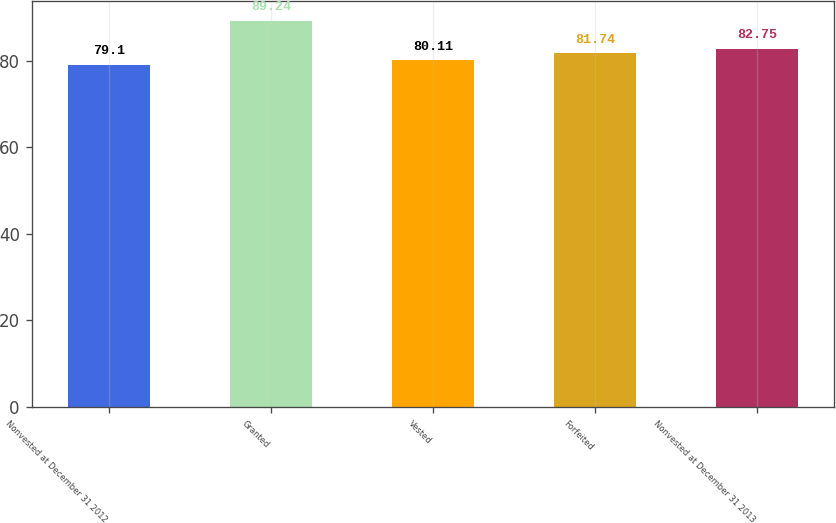Convert chart to OTSL. <chart><loc_0><loc_0><loc_500><loc_500><bar_chart><fcel>Nonvested at December 31 2012<fcel>Granted<fcel>Vested<fcel>Forfeited<fcel>Nonvested at December 31 2013<nl><fcel>79.1<fcel>89.24<fcel>80.11<fcel>81.74<fcel>82.75<nl></chart> 